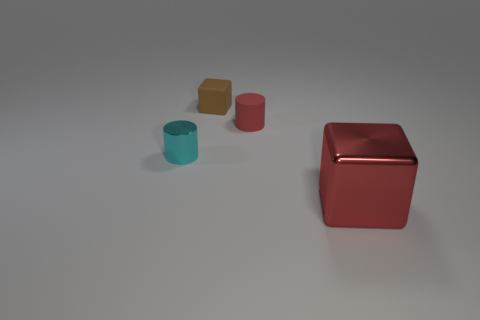Is there anything else of the same color as the large cube?
Your answer should be very brief. Yes. How many rubber objects are cylinders or tiny yellow blocks?
Provide a succinct answer. 1. What material is the red object behind the cube right of the red thing to the left of the big red cube?
Make the answer very short. Rubber. There is a small brown block behind the cylinder right of the tiny brown rubber thing; what is it made of?
Ensure brevity in your answer.  Rubber. There is a cube behind the large red metal cube; is its size the same as the red thing that is left of the big shiny block?
Offer a terse response. Yes. Is there anything else that is made of the same material as the small cyan cylinder?
Your answer should be very brief. Yes. How many small objects are either rubber blocks or green matte cylinders?
Your response must be concise. 1. What number of objects are small cylinders on the right side of the cyan object or cyan metallic spheres?
Provide a succinct answer. 1. Is the color of the rubber cylinder the same as the large object?
Offer a terse response. Yes. How many other things are there of the same shape as the small metal thing?
Your answer should be compact. 1. 